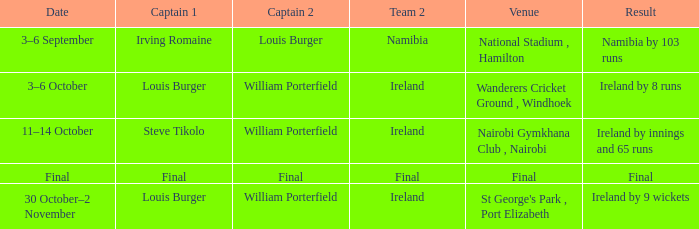Which Captain 2 has a Result of ireland by 8 runs? William Porterfield. 